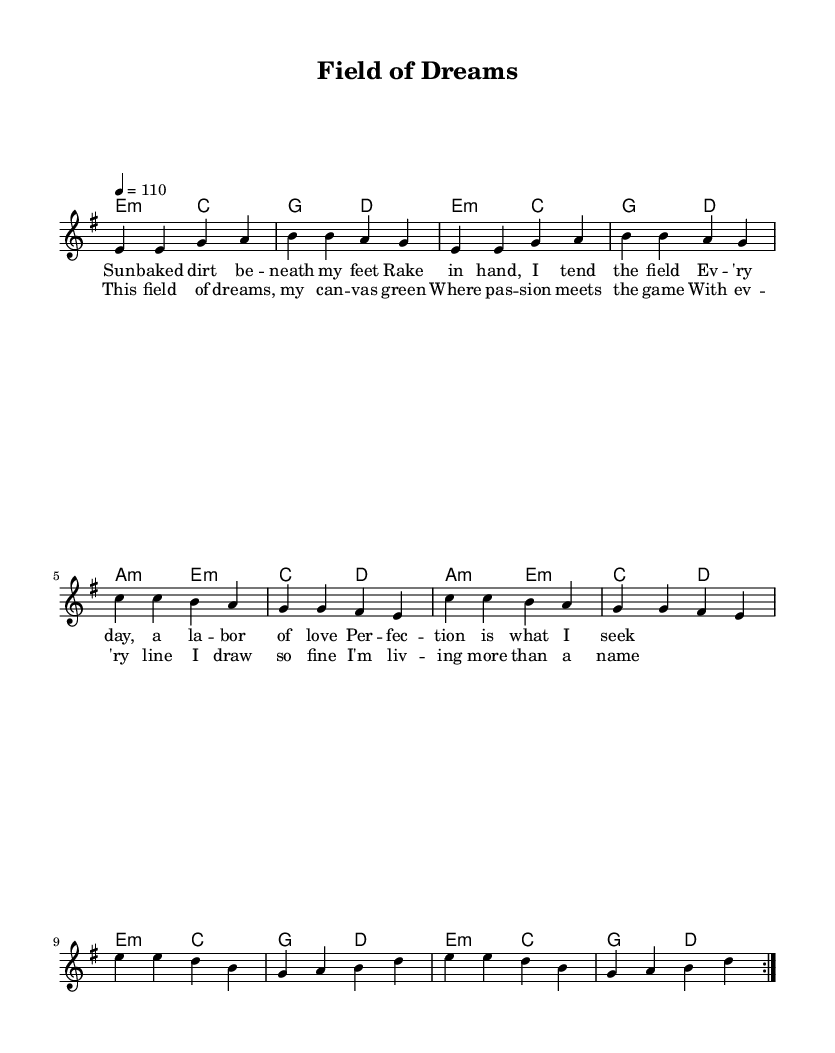What is the key signature of this music? The key signature is E minor, indicated by the presence of one sharp (F#) and their corresponding scale.
Answer: E minor What is the time signature of this music? The time signature is 4/4, as indicated by the denominator of 4, suggesting four beats per measure and being one of the most common time signatures in music.
Answer: 4/4 What is the tempo marking for this piece? The tempo marking is 110 beats per minute, which instructs the performer on the speed at which to play the piece.
Answer: 110 How many measures are repeated in the melody? The melody indicates a repeat of two measures, noted by the "volta" indication, suggesting that the melody should be played twice.
Answer: 2 What is the lyrical theme of the chorus? The lyrical theme of the chorus reflects passion and dedication to the field and game, emphasizing a connection to dreams and identity.
Answer: Passion and dedication Which section features the lyrics "This field of dreams, my canvas green"? These lyrics are found in the chorus section, where the key ideas of the song are emphasized melodically and lyrically.
Answer: Chorus What type of chord progression is primarily used in the harmonies? The chord progression includes minor and major chords, specifically E minor and A minor, which are common in Latin rock, establishing an emotional yet uplifting feel.
Answer: Minor and major chords 